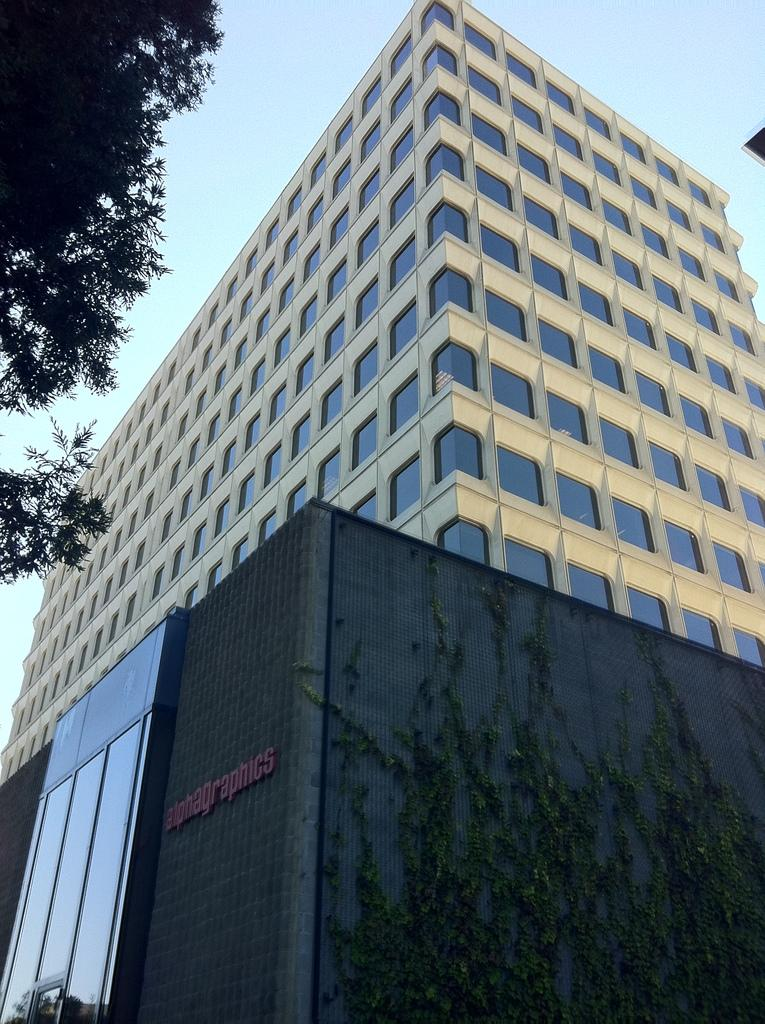What type of structure is present in the image? There is a building in the image. What can be seen in the background of the image? The sky is visible in the background of the image. Where is the tree located in the image? There is a tree on the top left of the image. Reasoning: Let's think step by following the guidelines to produce the conversation. We start by identifying the main subject in the image, which is the building. Then, we expand the conversation to include other elements that are also visible, such as the sky and the tree. Each question is designed to elicit a specific detail about the image that is known from the provided facts. Absurd Question/Answer: What type of yam is being prepared by the grandmother in the image? There is no yam or grandmother present in the image. What part of the city is depicted in the image? The image does not specify whether it is in downtown or any other part of the city. 